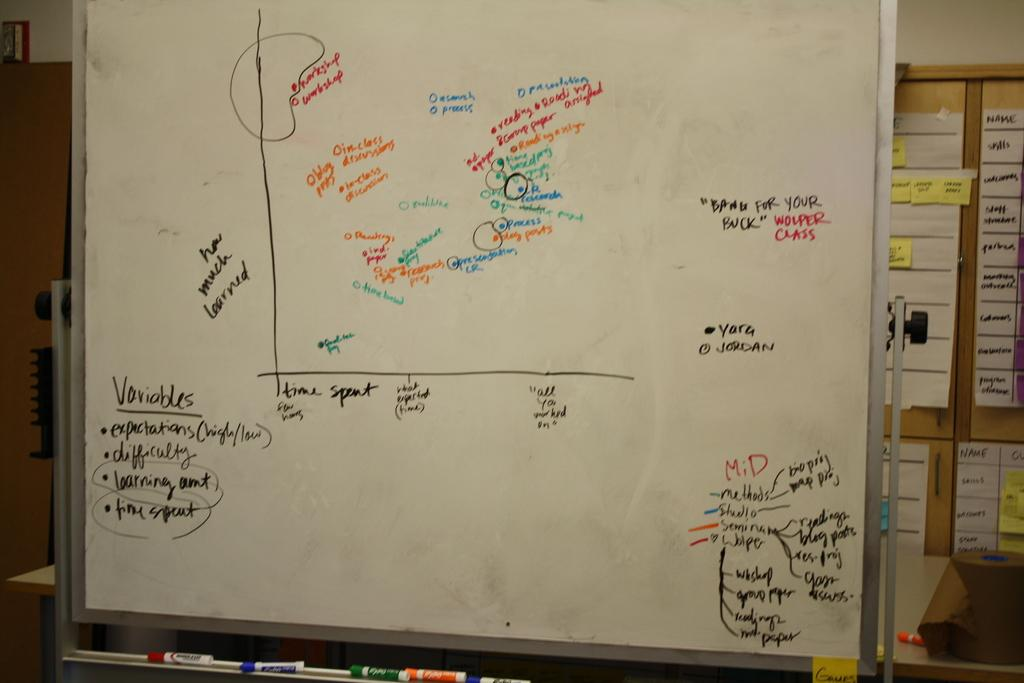<image>
Give a short and clear explanation of the subsequent image. A white board has a graph in the center and variables listed in the lower left corner. 